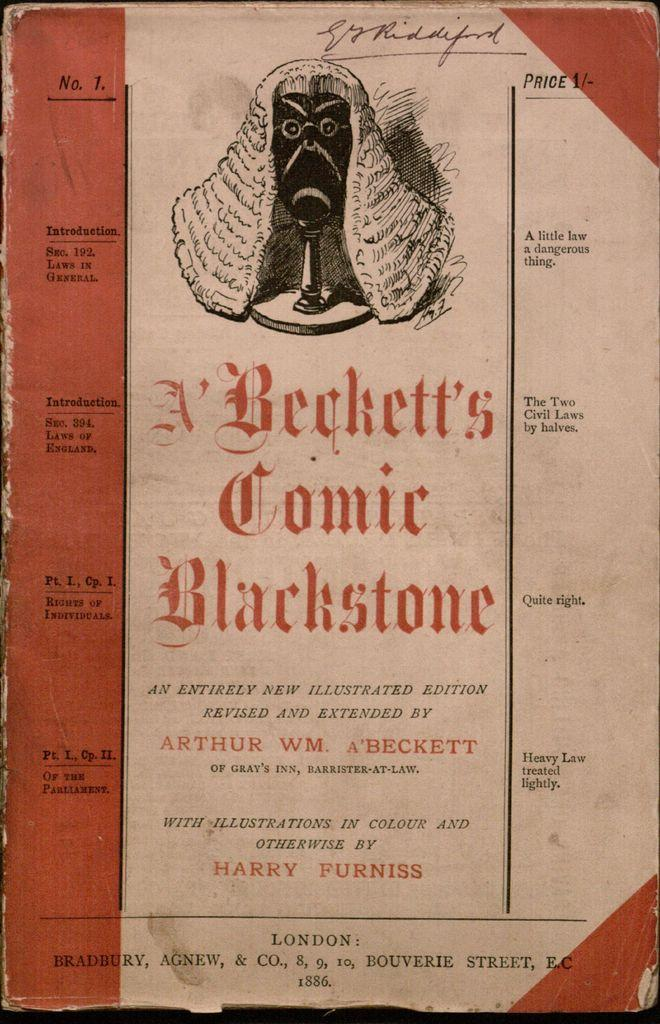What is the main subject of the image? The main subject of the image is the cover page of a book. What can be found on the cover page? The cover page has some text and an image on it. What type of net is visible on the cover page of the book? There is no net visible on the cover page of the book; it only has text and an image. 